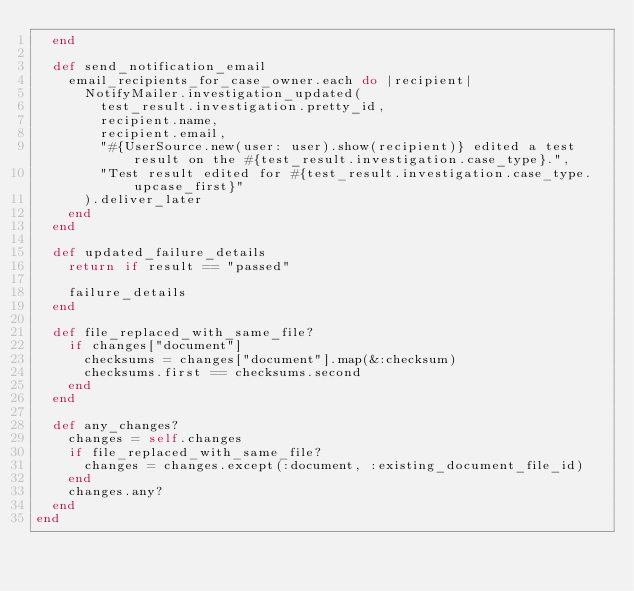<code> <loc_0><loc_0><loc_500><loc_500><_Ruby_>  end

  def send_notification_email
    email_recipients_for_case_owner.each do |recipient|
      NotifyMailer.investigation_updated(
        test_result.investigation.pretty_id,
        recipient.name,
        recipient.email,
        "#{UserSource.new(user: user).show(recipient)} edited a test result on the #{test_result.investigation.case_type}.",
        "Test result edited for #{test_result.investigation.case_type.upcase_first}"
      ).deliver_later
    end
  end

  def updated_failure_details
    return if result == "passed"

    failure_details
  end

  def file_replaced_with_same_file?
    if changes["document"]
      checksums = changes["document"].map(&:checksum)
      checksums.first == checksums.second
    end
  end

  def any_changes?
    changes = self.changes
    if file_replaced_with_same_file?
      changes = changes.except(:document, :existing_document_file_id)
    end
    changes.any?
  end
end
</code> 